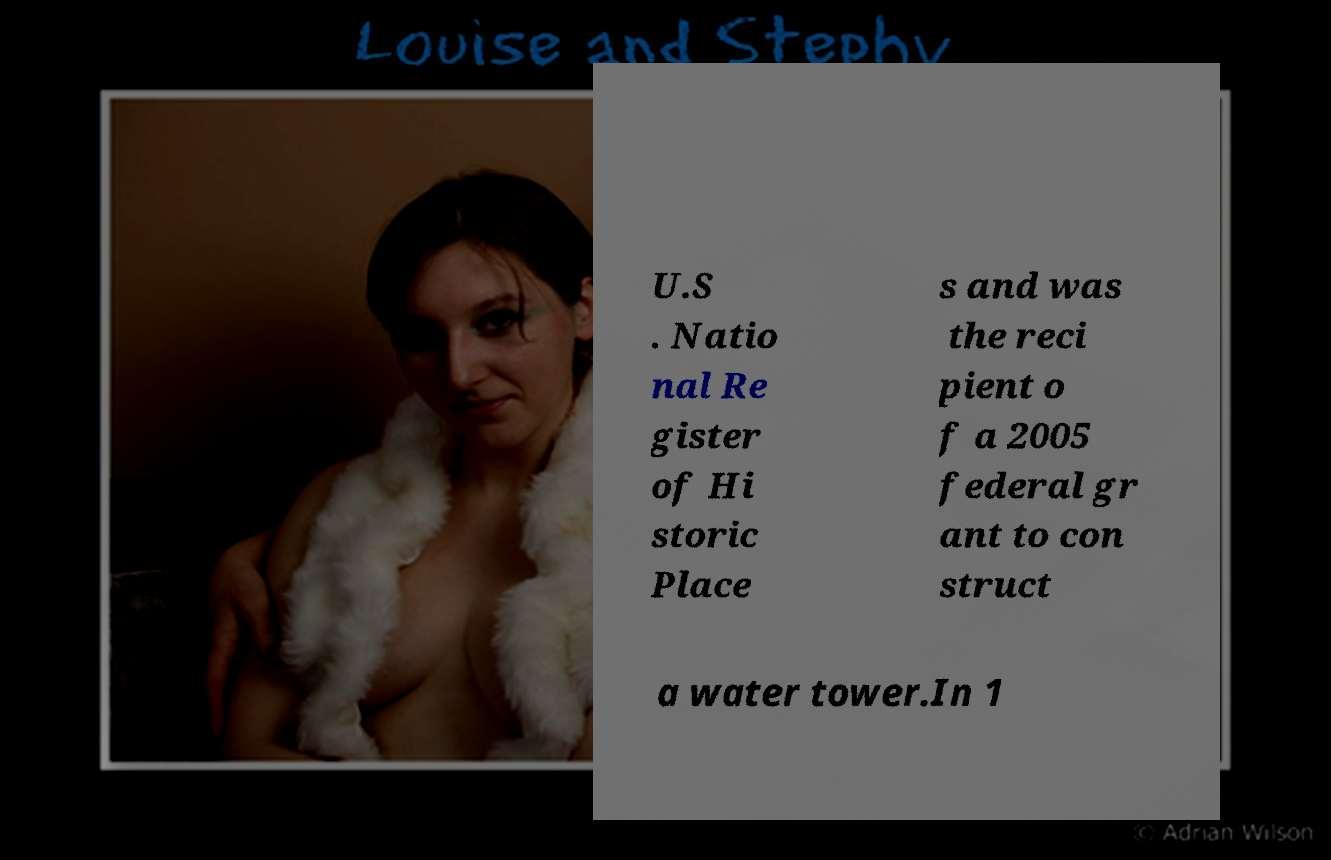Can you accurately transcribe the text from the provided image for me? U.S . Natio nal Re gister of Hi storic Place s and was the reci pient o f a 2005 federal gr ant to con struct a water tower.In 1 